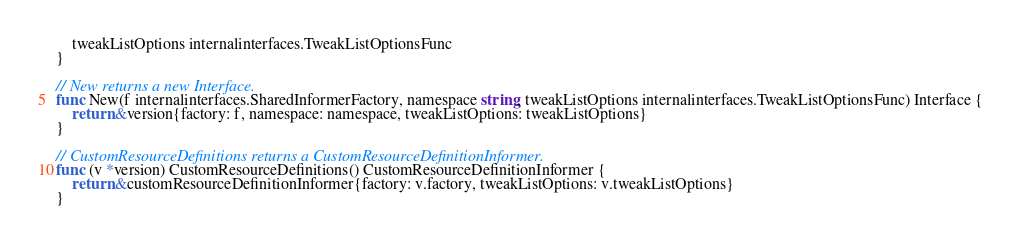Convert code to text. <code><loc_0><loc_0><loc_500><loc_500><_Go_>	tweakListOptions internalinterfaces.TweakListOptionsFunc
}

// New returns a new Interface.
func New(f internalinterfaces.SharedInformerFactory, namespace string, tweakListOptions internalinterfaces.TweakListOptionsFunc) Interface {
	return &version{factory: f, namespace: namespace, tweakListOptions: tweakListOptions}
}

// CustomResourceDefinitions returns a CustomResourceDefinitionInformer.
func (v *version) CustomResourceDefinitions() CustomResourceDefinitionInformer {
	return &customResourceDefinitionInformer{factory: v.factory, tweakListOptions: v.tweakListOptions}
}
</code> 